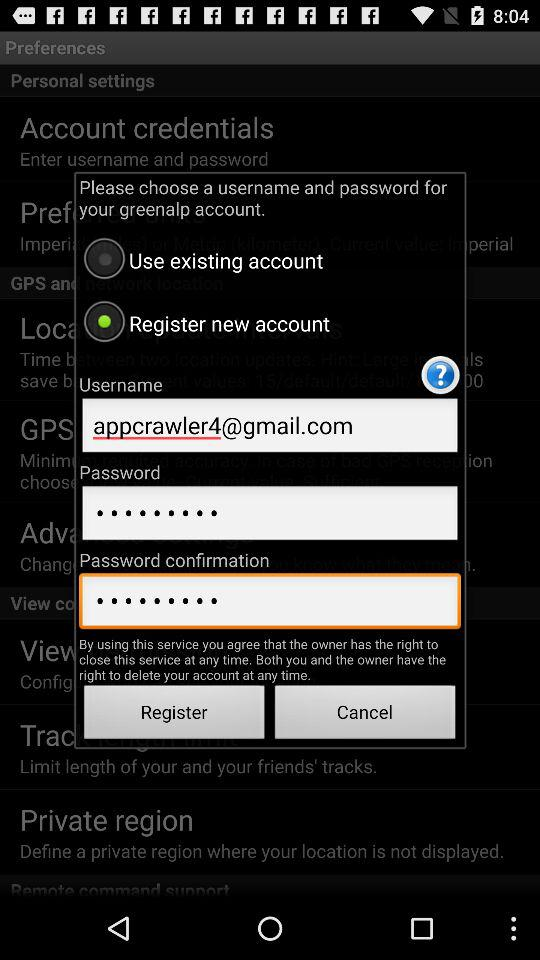Which option is selected? The selected option is "Register new account". 